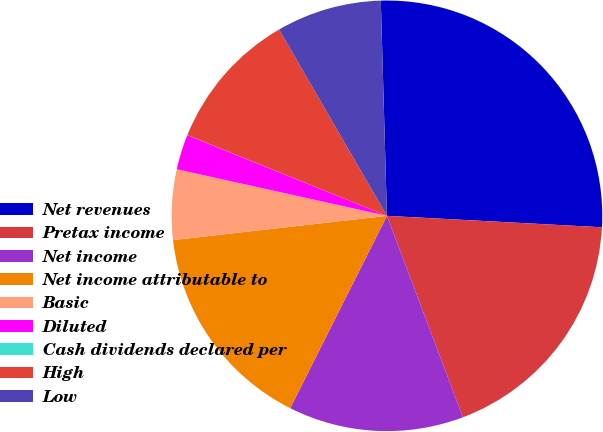Convert chart. <chart><loc_0><loc_0><loc_500><loc_500><pie_chart><fcel>Net revenues<fcel>Pretax income<fcel>Net income<fcel>Net income attributable to<fcel>Basic<fcel>Diluted<fcel>Cash dividends declared per<fcel>High<fcel>Low<nl><fcel>26.31%<fcel>18.42%<fcel>13.16%<fcel>15.79%<fcel>5.27%<fcel>2.64%<fcel>0.01%<fcel>10.53%<fcel>7.9%<nl></chart> 